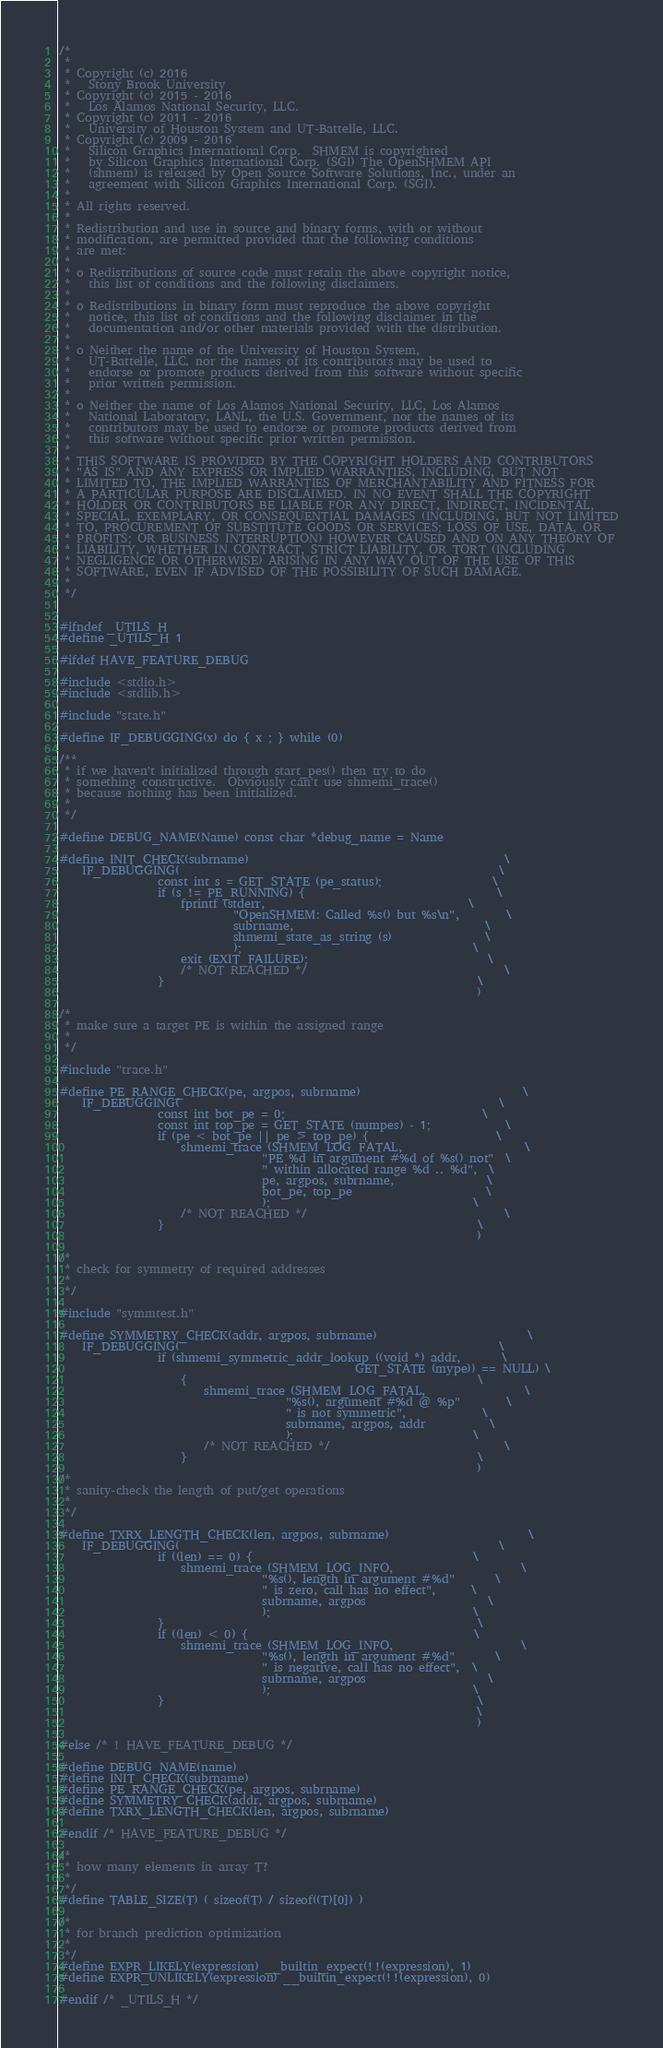<code> <loc_0><loc_0><loc_500><loc_500><_C_>/*
 *
 * Copyright (c) 2016
 *   Stony Brook University
 * Copyright (c) 2015 - 2016
 *   Los Alamos National Security, LLC.
 * Copyright (c) 2011 - 2016
 *   University of Houston System and UT-Battelle, LLC.
 * Copyright (c) 2009 - 2016
 *   Silicon Graphics International Corp.  SHMEM is copyrighted
 *   by Silicon Graphics International Corp. (SGI) The OpenSHMEM API
 *   (shmem) is released by Open Source Software Solutions, Inc., under an
 *   agreement with Silicon Graphics International Corp. (SGI).
 *
 * All rights reserved.
 *
 * Redistribution and use in source and binary forms, with or without
 * modification, are permitted provided that the following conditions
 * are met:
 *
 * o Redistributions of source code must retain the above copyright notice,
 *   this list of conditions and the following disclaimers.
 *
 * o Redistributions in binary form must reproduce the above copyright
 *   notice, this list of conditions and the following disclaimer in the
 *   documentation and/or other materials provided with the distribution.
 *
 * o Neither the name of the University of Houston System,
 *   UT-Battelle, LLC. nor the names of its contributors may be used to
 *   endorse or promote products derived from this software without specific
 *   prior written permission.
 *
 * o Neither the name of Los Alamos National Security, LLC, Los Alamos
 *   National Laboratory, LANL, the U.S. Government, nor the names of its
 *   contributors may be used to endorse or promote products derived from
 *   this software without specific prior written permission.
 *
 * THIS SOFTWARE IS PROVIDED BY THE COPYRIGHT HOLDERS AND CONTRIBUTORS
 * "AS IS" AND ANY EXPRESS OR IMPLIED WARRANTIES, INCLUDING, BUT NOT
 * LIMITED TO, THE IMPLIED WARRANTIES OF MERCHANTABILITY AND FITNESS FOR
 * A PARTICULAR PURPOSE ARE DISCLAIMED. IN NO EVENT SHALL THE COPYRIGHT
 * HOLDER OR CONTRIBUTORS BE LIABLE FOR ANY DIRECT, INDIRECT, INCIDENTAL,
 * SPECIAL, EXEMPLARY, OR CONSEQUENTIAL DAMAGES (INCLUDING, BUT NOT LIMITED
 * TO, PROCUREMENT OF SUBSTITUTE GOODS OR SERVICES; LOSS OF USE, DATA, OR
 * PROFITS; OR BUSINESS INTERRUPTION) HOWEVER CAUSED AND ON ANY THEORY OF
 * LIABILITY, WHETHER IN CONTRACT, STRICT LIABILITY, OR TORT (INCLUDING
 * NEGLIGENCE OR OTHERWISE) ARISING IN ANY WAY OUT OF THE USE OF THIS
 * SOFTWARE, EVEN IF ADVISED OF THE POSSIBILITY OF SUCH DAMAGE.
 *
 */


#ifndef _UTILS_H
#define _UTILS_H 1

#ifdef HAVE_FEATURE_DEBUG

#include <stdio.h>
#include <stdlib.h>

#include "state.h"

#define IF_DEBUGGING(x) do { x ; } while (0)

/**
 * if we haven't initialized through start_pes() then try to do
 * something constructive.  Obviously can't use shmemi_trace()
 * because nothing has been initialized.
 *
 */

#define DEBUG_NAME(Name) const char *debug_name = Name

#define INIT_CHECK(subrname)                                            \
    IF_DEBUGGING(                                                       \
                 const int s = GET_STATE (pe_status);                   \
                 if (s != PE_RUNNING) {                                 \
                     fprintf (stderr,                                   \
                              "OpenSHMEM: Called %s() but %s\n",        \
                              subrname,                                 \
                              shmemi_state_as_string (s)                \
                              );                                        \
                     exit (EXIT_FAILURE);                               \
                     /* NOT REACHED */                                  \
                 }                                                      \
                                                                        )

/*
 * make sure a target PE is within the assigned range
 *
 */

#include "trace.h"

#define PE_RANGE_CHECK(pe, argpos, subrname)                            \
    IF_DEBUGGING(                                                       \
                 const int bot_pe = 0;                                  \
                 const int top_pe = GET_STATE (numpes) - 1;             \
                 if (pe < bot_pe || pe > top_pe) {                      \
                     shmemi_trace (SHMEM_LOG_FATAL,                     \
                                   "PE %d in argument #%d of %s() not"  \
                                   " within allocated range %d .. %d",  \
                                   pe, argpos, subrname,                \
                                   bot_pe, top_pe                       \
                                   );                                   \
                     /* NOT REACHED */                                  \
                 }                                                      \
                                                                        )

/*
 * check for symmetry of required addresses
 *
 */

#include "symmtest.h"

#define SYMMETRY_CHECK(addr, argpos, subrname)                          \
    IF_DEBUGGING(                                                       \
                 if (shmemi_symmetric_addr_lookup ((void *) addr,       \
                                                   GET_STATE (mype)) == NULL) \
                     {                                                  \
                         shmemi_trace (SHMEM_LOG_FATAL,                 \
                                       "%s(), argument #%d @ %p"        \
                                       " is not symmetric",             \
                                       subrname, argpos, addr           \
                                       );                               \
                         /* NOT REACHED */                              \
                     }                                                  \
                                                                        )
/*
 * sanity-check the length of put/get operations
 *
 */

#define TXRX_LENGTH_CHECK(len, argpos, subrname)                        \
    IF_DEBUGGING(                                                       \
                 if ((len) == 0) {                                      \
                     shmemi_trace (SHMEM_LOG_INFO,                      \
                                   "%s(), length in argument #%d"       \
                                   " is zero, call has no effect",      \
                                   subrname, argpos                     \
                                   );                                   \
                 }                                                      \
                 if ((len) < 0) {                                       \
                     shmemi_trace (SHMEM_LOG_INFO,                      \
                                   "%s(), length in argument #%d"       \
                                   " is negative, call has no effect",  \
                                   subrname, argpos                     \
                                   );                                   \
                 }                                                      \
                                                                        \
                                                                        )

#else /* ! HAVE_FEATURE_DEBUG */

#define DEBUG_NAME(name)
#define INIT_CHECK(subrname)
#define PE_RANGE_CHECK(pe, argpos, subrname)
#define SYMMETRY_CHECK(addr, argpos, subrname)
#define TXRX_LENGTH_CHECK(len, argpos, subrname)

#endif /* HAVE_FEATURE_DEBUG */

/*
 * how many elements in array T?
 *
 */
#define TABLE_SIZE(T) ( sizeof(T) / sizeof((T)[0]) )

/*
 * for branch prediction optimization
 *
 */
#define EXPR_LIKELY(expression) __builtin_expect(!!(expression), 1)
#define EXPR_UNLIKELY(expression) __builtin_expect(!!(expression), 0)

#endif /* _UTILS_H */
</code> 